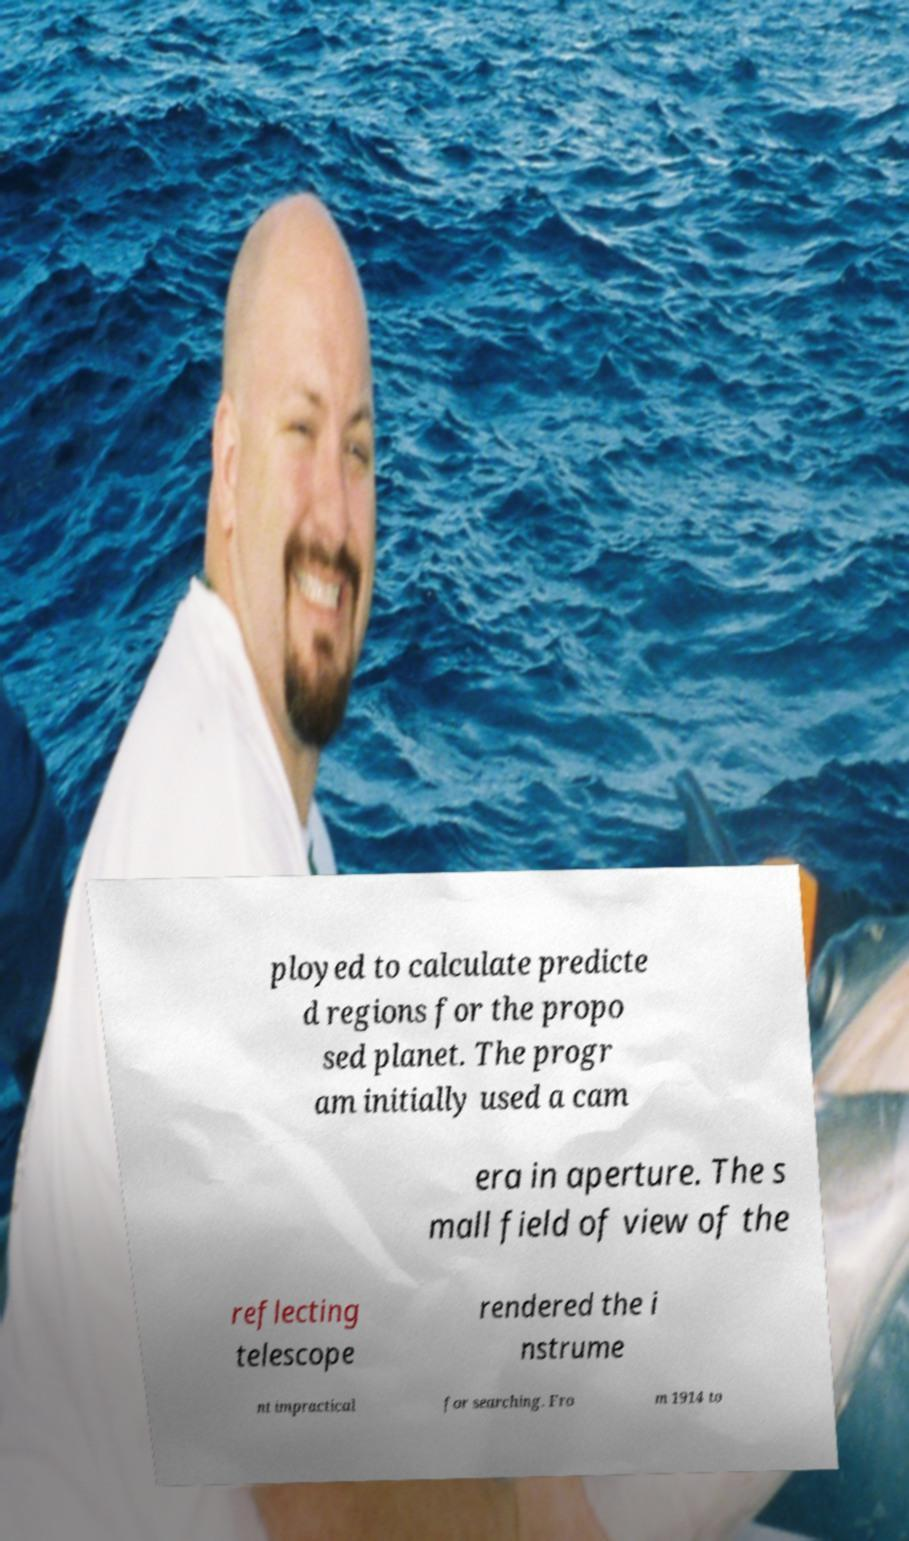Could you assist in decoding the text presented in this image and type it out clearly? ployed to calculate predicte d regions for the propo sed planet. The progr am initially used a cam era in aperture. The s mall field of view of the reflecting telescope rendered the i nstrume nt impractical for searching. Fro m 1914 to 